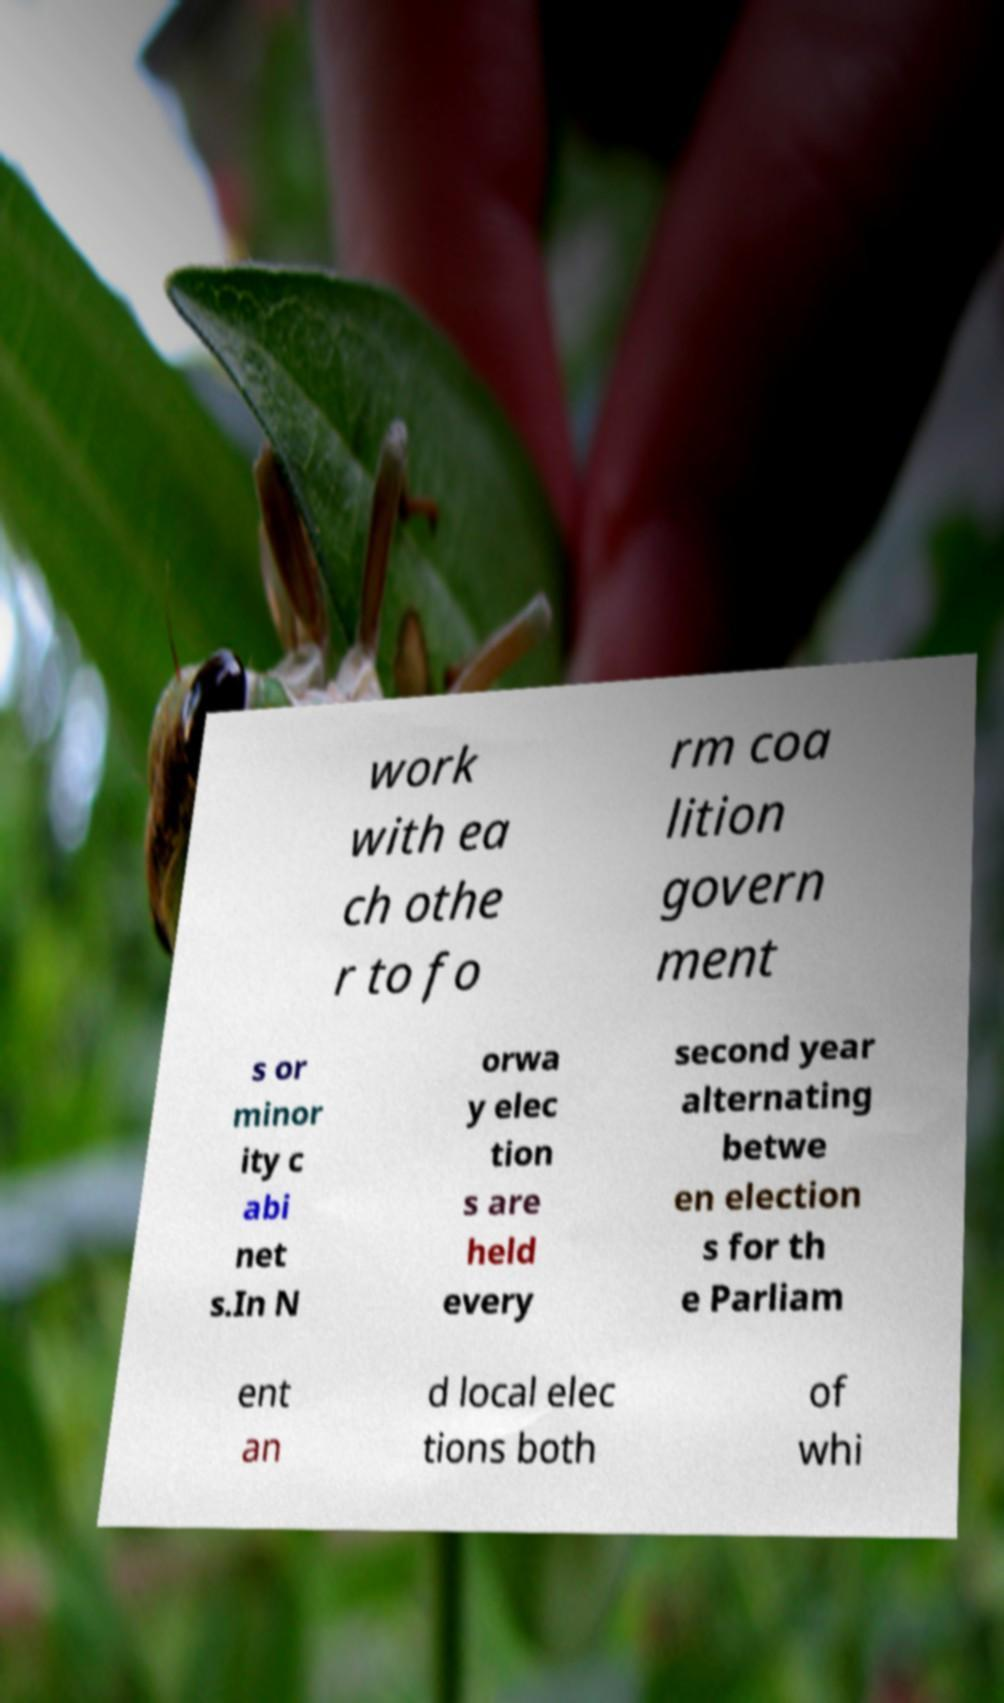Please identify and transcribe the text found in this image. work with ea ch othe r to fo rm coa lition govern ment s or minor ity c abi net s.In N orwa y elec tion s are held every second year alternating betwe en election s for th e Parliam ent an d local elec tions both of whi 